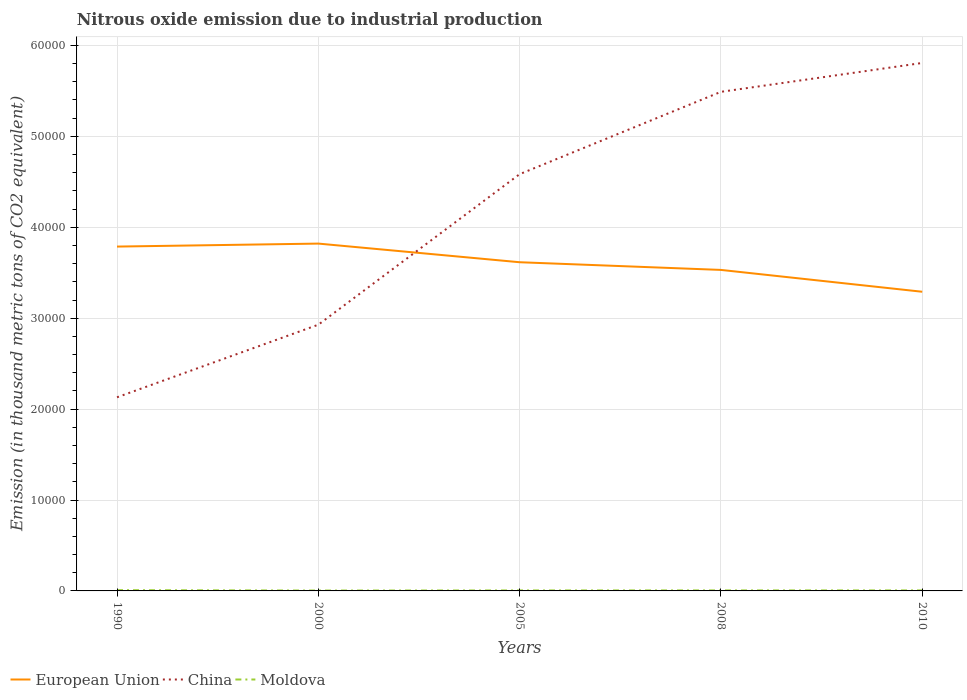How many different coloured lines are there?
Offer a very short reply. 3. Is the number of lines equal to the number of legend labels?
Offer a very short reply. Yes. Across all years, what is the maximum amount of nitrous oxide emitted in China?
Give a very brief answer. 2.13e+04. What is the total amount of nitrous oxide emitted in Moldova in the graph?
Keep it short and to the point. 29.4. What is the difference between the highest and the second highest amount of nitrous oxide emitted in China?
Offer a terse response. 3.68e+04. Is the amount of nitrous oxide emitted in China strictly greater than the amount of nitrous oxide emitted in Moldova over the years?
Your answer should be very brief. No. How many lines are there?
Ensure brevity in your answer.  3. Does the graph contain any zero values?
Your answer should be very brief. No. Where does the legend appear in the graph?
Make the answer very short. Bottom left. How many legend labels are there?
Provide a short and direct response. 3. What is the title of the graph?
Provide a short and direct response. Nitrous oxide emission due to industrial production. Does "French Polynesia" appear as one of the legend labels in the graph?
Provide a succinct answer. No. What is the label or title of the X-axis?
Your response must be concise. Years. What is the label or title of the Y-axis?
Offer a terse response. Emission (in thousand metric tons of CO2 equivalent). What is the Emission (in thousand metric tons of CO2 equivalent) in European Union in 1990?
Provide a succinct answer. 3.79e+04. What is the Emission (in thousand metric tons of CO2 equivalent) in China in 1990?
Your response must be concise. 2.13e+04. What is the Emission (in thousand metric tons of CO2 equivalent) in Moldova in 1990?
Ensure brevity in your answer.  84.7. What is the Emission (in thousand metric tons of CO2 equivalent) in European Union in 2000?
Give a very brief answer. 3.82e+04. What is the Emission (in thousand metric tons of CO2 equivalent) in China in 2000?
Your answer should be very brief. 2.93e+04. What is the Emission (in thousand metric tons of CO2 equivalent) of Moldova in 2000?
Provide a short and direct response. 40.8. What is the Emission (in thousand metric tons of CO2 equivalent) in European Union in 2005?
Your response must be concise. 3.62e+04. What is the Emission (in thousand metric tons of CO2 equivalent) in China in 2005?
Your answer should be compact. 4.58e+04. What is the Emission (in thousand metric tons of CO2 equivalent) in Moldova in 2005?
Your answer should be very brief. 52.6. What is the Emission (in thousand metric tons of CO2 equivalent) of European Union in 2008?
Keep it short and to the point. 3.53e+04. What is the Emission (in thousand metric tons of CO2 equivalent) of China in 2008?
Provide a short and direct response. 5.49e+04. What is the Emission (in thousand metric tons of CO2 equivalent) in Moldova in 2008?
Provide a short and direct response. 55.7. What is the Emission (in thousand metric tons of CO2 equivalent) of European Union in 2010?
Provide a short and direct response. 3.29e+04. What is the Emission (in thousand metric tons of CO2 equivalent) in China in 2010?
Provide a short and direct response. 5.81e+04. What is the Emission (in thousand metric tons of CO2 equivalent) of Moldova in 2010?
Provide a short and direct response. 55.3. Across all years, what is the maximum Emission (in thousand metric tons of CO2 equivalent) of European Union?
Make the answer very short. 3.82e+04. Across all years, what is the maximum Emission (in thousand metric tons of CO2 equivalent) in China?
Offer a terse response. 5.81e+04. Across all years, what is the maximum Emission (in thousand metric tons of CO2 equivalent) of Moldova?
Give a very brief answer. 84.7. Across all years, what is the minimum Emission (in thousand metric tons of CO2 equivalent) of European Union?
Provide a succinct answer. 3.29e+04. Across all years, what is the minimum Emission (in thousand metric tons of CO2 equivalent) in China?
Make the answer very short. 2.13e+04. Across all years, what is the minimum Emission (in thousand metric tons of CO2 equivalent) in Moldova?
Your answer should be very brief. 40.8. What is the total Emission (in thousand metric tons of CO2 equivalent) of European Union in the graph?
Provide a short and direct response. 1.80e+05. What is the total Emission (in thousand metric tons of CO2 equivalent) in China in the graph?
Offer a very short reply. 2.09e+05. What is the total Emission (in thousand metric tons of CO2 equivalent) of Moldova in the graph?
Ensure brevity in your answer.  289.1. What is the difference between the Emission (in thousand metric tons of CO2 equivalent) in European Union in 1990 and that in 2000?
Your answer should be very brief. -328.9. What is the difference between the Emission (in thousand metric tons of CO2 equivalent) of China in 1990 and that in 2000?
Keep it short and to the point. -7984.9. What is the difference between the Emission (in thousand metric tons of CO2 equivalent) of Moldova in 1990 and that in 2000?
Provide a succinct answer. 43.9. What is the difference between the Emission (in thousand metric tons of CO2 equivalent) of European Union in 1990 and that in 2005?
Offer a very short reply. 1721.7. What is the difference between the Emission (in thousand metric tons of CO2 equivalent) in China in 1990 and that in 2005?
Keep it short and to the point. -2.45e+04. What is the difference between the Emission (in thousand metric tons of CO2 equivalent) of Moldova in 1990 and that in 2005?
Your answer should be very brief. 32.1. What is the difference between the Emission (in thousand metric tons of CO2 equivalent) in European Union in 1990 and that in 2008?
Offer a very short reply. 2566.7. What is the difference between the Emission (in thousand metric tons of CO2 equivalent) of China in 1990 and that in 2008?
Offer a terse response. -3.36e+04. What is the difference between the Emission (in thousand metric tons of CO2 equivalent) of Moldova in 1990 and that in 2008?
Your response must be concise. 29. What is the difference between the Emission (in thousand metric tons of CO2 equivalent) in European Union in 1990 and that in 2010?
Offer a very short reply. 4969.2. What is the difference between the Emission (in thousand metric tons of CO2 equivalent) in China in 1990 and that in 2010?
Keep it short and to the point. -3.68e+04. What is the difference between the Emission (in thousand metric tons of CO2 equivalent) in Moldova in 1990 and that in 2010?
Make the answer very short. 29.4. What is the difference between the Emission (in thousand metric tons of CO2 equivalent) in European Union in 2000 and that in 2005?
Your response must be concise. 2050.6. What is the difference between the Emission (in thousand metric tons of CO2 equivalent) of China in 2000 and that in 2005?
Offer a terse response. -1.66e+04. What is the difference between the Emission (in thousand metric tons of CO2 equivalent) of European Union in 2000 and that in 2008?
Give a very brief answer. 2895.6. What is the difference between the Emission (in thousand metric tons of CO2 equivalent) of China in 2000 and that in 2008?
Offer a terse response. -2.56e+04. What is the difference between the Emission (in thousand metric tons of CO2 equivalent) in Moldova in 2000 and that in 2008?
Make the answer very short. -14.9. What is the difference between the Emission (in thousand metric tons of CO2 equivalent) in European Union in 2000 and that in 2010?
Offer a very short reply. 5298.1. What is the difference between the Emission (in thousand metric tons of CO2 equivalent) in China in 2000 and that in 2010?
Give a very brief answer. -2.88e+04. What is the difference between the Emission (in thousand metric tons of CO2 equivalent) in Moldova in 2000 and that in 2010?
Provide a succinct answer. -14.5. What is the difference between the Emission (in thousand metric tons of CO2 equivalent) in European Union in 2005 and that in 2008?
Your answer should be very brief. 845. What is the difference between the Emission (in thousand metric tons of CO2 equivalent) in China in 2005 and that in 2008?
Provide a succinct answer. -9056.8. What is the difference between the Emission (in thousand metric tons of CO2 equivalent) of European Union in 2005 and that in 2010?
Make the answer very short. 3247.5. What is the difference between the Emission (in thousand metric tons of CO2 equivalent) in China in 2005 and that in 2010?
Your answer should be very brief. -1.22e+04. What is the difference between the Emission (in thousand metric tons of CO2 equivalent) of European Union in 2008 and that in 2010?
Give a very brief answer. 2402.5. What is the difference between the Emission (in thousand metric tons of CO2 equivalent) of China in 2008 and that in 2010?
Make the answer very short. -3175.5. What is the difference between the Emission (in thousand metric tons of CO2 equivalent) of European Union in 1990 and the Emission (in thousand metric tons of CO2 equivalent) of China in 2000?
Make the answer very short. 8592.7. What is the difference between the Emission (in thousand metric tons of CO2 equivalent) of European Union in 1990 and the Emission (in thousand metric tons of CO2 equivalent) of Moldova in 2000?
Provide a succinct answer. 3.78e+04. What is the difference between the Emission (in thousand metric tons of CO2 equivalent) in China in 1990 and the Emission (in thousand metric tons of CO2 equivalent) in Moldova in 2000?
Your response must be concise. 2.13e+04. What is the difference between the Emission (in thousand metric tons of CO2 equivalent) in European Union in 1990 and the Emission (in thousand metric tons of CO2 equivalent) in China in 2005?
Ensure brevity in your answer.  -7965.7. What is the difference between the Emission (in thousand metric tons of CO2 equivalent) of European Union in 1990 and the Emission (in thousand metric tons of CO2 equivalent) of Moldova in 2005?
Keep it short and to the point. 3.78e+04. What is the difference between the Emission (in thousand metric tons of CO2 equivalent) of China in 1990 and the Emission (in thousand metric tons of CO2 equivalent) of Moldova in 2005?
Your response must be concise. 2.12e+04. What is the difference between the Emission (in thousand metric tons of CO2 equivalent) in European Union in 1990 and the Emission (in thousand metric tons of CO2 equivalent) in China in 2008?
Your answer should be compact. -1.70e+04. What is the difference between the Emission (in thousand metric tons of CO2 equivalent) of European Union in 1990 and the Emission (in thousand metric tons of CO2 equivalent) of Moldova in 2008?
Offer a very short reply. 3.78e+04. What is the difference between the Emission (in thousand metric tons of CO2 equivalent) of China in 1990 and the Emission (in thousand metric tons of CO2 equivalent) of Moldova in 2008?
Offer a terse response. 2.12e+04. What is the difference between the Emission (in thousand metric tons of CO2 equivalent) of European Union in 1990 and the Emission (in thousand metric tons of CO2 equivalent) of China in 2010?
Keep it short and to the point. -2.02e+04. What is the difference between the Emission (in thousand metric tons of CO2 equivalent) in European Union in 1990 and the Emission (in thousand metric tons of CO2 equivalent) in Moldova in 2010?
Make the answer very short. 3.78e+04. What is the difference between the Emission (in thousand metric tons of CO2 equivalent) in China in 1990 and the Emission (in thousand metric tons of CO2 equivalent) in Moldova in 2010?
Your answer should be compact. 2.12e+04. What is the difference between the Emission (in thousand metric tons of CO2 equivalent) of European Union in 2000 and the Emission (in thousand metric tons of CO2 equivalent) of China in 2005?
Offer a terse response. -7636.8. What is the difference between the Emission (in thousand metric tons of CO2 equivalent) of European Union in 2000 and the Emission (in thousand metric tons of CO2 equivalent) of Moldova in 2005?
Make the answer very short. 3.82e+04. What is the difference between the Emission (in thousand metric tons of CO2 equivalent) of China in 2000 and the Emission (in thousand metric tons of CO2 equivalent) of Moldova in 2005?
Your response must be concise. 2.92e+04. What is the difference between the Emission (in thousand metric tons of CO2 equivalent) in European Union in 2000 and the Emission (in thousand metric tons of CO2 equivalent) in China in 2008?
Your answer should be very brief. -1.67e+04. What is the difference between the Emission (in thousand metric tons of CO2 equivalent) of European Union in 2000 and the Emission (in thousand metric tons of CO2 equivalent) of Moldova in 2008?
Your response must be concise. 3.81e+04. What is the difference between the Emission (in thousand metric tons of CO2 equivalent) of China in 2000 and the Emission (in thousand metric tons of CO2 equivalent) of Moldova in 2008?
Keep it short and to the point. 2.92e+04. What is the difference between the Emission (in thousand metric tons of CO2 equivalent) of European Union in 2000 and the Emission (in thousand metric tons of CO2 equivalent) of China in 2010?
Ensure brevity in your answer.  -1.99e+04. What is the difference between the Emission (in thousand metric tons of CO2 equivalent) in European Union in 2000 and the Emission (in thousand metric tons of CO2 equivalent) in Moldova in 2010?
Keep it short and to the point. 3.81e+04. What is the difference between the Emission (in thousand metric tons of CO2 equivalent) in China in 2000 and the Emission (in thousand metric tons of CO2 equivalent) in Moldova in 2010?
Offer a terse response. 2.92e+04. What is the difference between the Emission (in thousand metric tons of CO2 equivalent) in European Union in 2005 and the Emission (in thousand metric tons of CO2 equivalent) in China in 2008?
Make the answer very short. -1.87e+04. What is the difference between the Emission (in thousand metric tons of CO2 equivalent) in European Union in 2005 and the Emission (in thousand metric tons of CO2 equivalent) in Moldova in 2008?
Ensure brevity in your answer.  3.61e+04. What is the difference between the Emission (in thousand metric tons of CO2 equivalent) in China in 2005 and the Emission (in thousand metric tons of CO2 equivalent) in Moldova in 2008?
Your answer should be very brief. 4.58e+04. What is the difference between the Emission (in thousand metric tons of CO2 equivalent) in European Union in 2005 and the Emission (in thousand metric tons of CO2 equivalent) in China in 2010?
Your response must be concise. -2.19e+04. What is the difference between the Emission (in thousand metric tons of CO2 equivalent) of European Union in 2005 and the Emission (in thousand metric tons of CO2 equivalent) of Moldova in 2010?
Your answer should be very brief. 3.61e+04. What is the difference between the Emission (in thousand metric tons of CO2 equivalent) of China in 2005 and the Emission (in thousand metric tons of CO2 equivalent) of Moldova in 2010?
Make the answer very short. 4.58e+04. What is the difference between the Emission (in thousand metric tons of CO2 equivalent) of European Union in 2008 and the Emission (in thousand metric tons of CO2 equivalent) of China in 2010?
Offer a very short reply. -2.28e+04. What is the difference between the Emission (in thousand metric tons of CO2 equivalent) in European Union in 2008 and the Emission (in thousand metric tons of CO2 equivalent) in Moldova in 2010?
Ensure brevity in your answer.  3.53e+04. What is the difference between the Emission (in thousand metric tons of CO2 equivalent) in China in 2008 and the Emission (in thousand metric tons of CO2 equivalent) in Moldova in 2010?
Keep it short and to the point. 5.48e+04. What is the average Emission (in thousand metric tons of CO2 equivalent) in European Union per year?
Keep it short and to the point. 3.61e+04. What is the average Emission (in thousand metric tons of CO2 equivalent) of China per year?
Your answer should be very brief. 4.19e+04. What is the average Emission (in thousand metric tons of CO2 equivalent) of Moldova per year?
Provide a short and direct response. 57.82. In the year 1990, what is the difference between the Emission (in thousand metric tons of CO2 equivalent) of European Union and Emission (in thousand metric tons of CO2 equivalent) of China?
Make the answer very short. 1.66e+04. In the year 1990, what is the difference between the Emission (in thousand metric tons of CO2 equivalent) in European Union and Emission (in thousand metric tons of CO2 equivalent) in Moldova?
Provide a succinct answer. 3.78e+04. In the year 1990, what is the difference between the Emission (in thousand metric tons of CO2 equivalent) of China and Emission (in thousand metric tons of CO2 equivalent) of Moldova?
Give a very brief answer. 2.12e+04. In the year 2000, what is the difference between the Emission (in thousand metric tons of CO2 equivalent) of European Union and Emission (in thousand metric tons of CO2 equivalent) of China?
Ensure brevity in your answer.  8921.6. In the year 2000, what is the difference between the Emission (in thousand metric tons of CO2 equivalent) in European Union and Emission (in thousand metric tons of CO2 equivalent) in Moldova?
Ensure brevity in your answer.  3.82e+04. In the year 2000, what is the difference between the Emission (in thousand metric tons of CO2 equivalent) of China and Emission (in thousand metric tons of CO2 equivalent) of Moldova?
Provide a succinct answer. 2.92e+04. In the year 2005, what is the difference between the Emission (in thousand metric tons of CO2 equivalent) of European Union and Emission (in thousand metric tons of CO2 equivalent) of China?
Offer a very short reply. -9687.4. In the year 2005, what is the difference between the Emission (in thousand metric tons of CO2 equivalent) in European Union and Emission (in thousand metric tons of CO2 equivalent) in Moldova?
Provide a succinct answer. 3.61e+04. In the year 2005, what is the difference between the Emission (in thousand metric tons of CO2 equivalent) in China and Emission (in thousand metric tons of CO2 equivalent) in Moldova?
Your response must be concise. 4.58e+04. In the year 2008, what is the difference between the Emission (in thousand metric tons of CO2 equivalent) of European Union and Emission (in thousand metric tons of CO2 equivalent) of China?
Offer a terse response. -1.96e+04. In the year 2008, what is the difference between the Emission (in thousand metric tons of CO2 equivalent) in European Union and Emission (in thousand metric tons of CO2 equivalent) in Moldova?
Offer a very short reply. 3.53e+04. In the year 2008, what is the difference between the Emission (in thousand metric tons of CO2 equivalent) in China and Emission (in thousand metric tons of CO2 equivalent) in Moldova?
Give a very brief answer. 5.48e+04. In the year 2010, what is the difference between the Emission (in thousand metric tons of CO2 equivalent) in European Union and Emission (in thousand metric tons of CO2 equivalent) in China?
Provide a succinct answer. -2.52e+04. In the year 2010, what is the difference between the Emission (in thousand metric tons of CO2 equivalent) in European Union and Emission (in thousand metric tons of CO2 equivalent) in Moldova?
Give a very brief answer. 3.29e+04. In the year 2010, what is the difference between the Emission (in thousand metric tons of CO2 equivalent) of China and Emission (in thousand metric tons of CO2 equivalent) of Moldova?
Your answer should be compact. 5.80e+04. What is the ratio of the Emission (in thousand metric tons of CO2 equivalent) of China in 1990 to that in 2000?
Your answer should be very brief. 0.73. What is the ratio of the Emission (in thousand metric tons of CO2 equivalent) in Moldova in 1990 to that in 2000?
Your answer should be compact. 2.08. What is the ratio of the Emission (in thousand metric tons of CO2 equivalent) of European Union in 1990 to that in 2005?
Provide a short and direct response. 1.05. What is the ratio of the Emission (in thousand metric tons of CO2 equivalent) in China in 1990 to that in 2005?
Keep it short and to the point. 0.46. What is the ratio of the Emission (in thousand metric tons of CO2 equivalent) in Moldova in 1990 to that in 2005?
Give a very brief answer. 1.61. What is the ratio of the Emission (in thousand metric tons of CO2 equivalent) in European Union in 1990 to that in 2008?
Your response must be concise. 1.07. What is the ratio of the Emission (in thousand metric tons of CO2 equivalent) in China in 1990 to that in 2008?
Provide a short and direct response. 0.39. What is the ratio of the Emission (in thousand metric tons of CO2 equivalent) of Moldova in 1990 to that in 2008?
Your answer should be very brief. 1.52. What is the ratio of the Emission (in thousand metric tons of CO2 equivalent) of European Union in 1990 to that in 2010?
Offer a terse response. 1.15. What is the ratio of the Emission (in thousand metric tons of CO2 equivalent) of China in 1990 to that in 2010?
Your answer should be compact. 0.37. What is the ratio of the Emission (in thousand metric tons of CO2 equivalent) of Moldova in 1990 to that in 2010?
Make the answer very short. 1.53. What is the ratio of the Emission (in thousand metric tons of CO2 equivalent) in European Union in 2000 to that in 2005?
Provide a succinct answer. 1.06. What is the ratio of the Emission (in thousand metric tons of CO2 equivalent) of China in 2000 to that in 2005?
Offer a very short reply. 0.64. What is the ratio of the Emission (in thousand metric tons of CO2 equivalent) in Moldova in 2000 to that in 2005?
Offer a terse response. 0.78. What is the ratio of the Emission (in thousand metric tons of CO2 equivalent) of European Union in 2000 to that in 2008?
Offer a terse response. 1.08. What is the ratio of the Emission (in thousand metric tons of CO2 equivalent) in China in 2000 to that in 2008?
Keep it short and to the point. 0.53. What is the ratio of the Emission (in thousand metric tons of CO2 equivalent) in Moldova in 2000 to that in 2008?
Offer a terse response. 0.73. What is the ratio of the Emission (in thousand metric tons of CO2 equivalent) in European Union in 2000 to that in 2010?
Your response must be concise. 1.16. What is the ratio of the Emission (in thousand metric tons of CO2 equivalent) of China in 2000 to that in 2010?
Keep it short and to the point. 0.5. What is the ratio of the Emission (in thousand metric tons of CO2 equivalent) of Moldova in 2000 to that in 2010?
Provide a short and direct response. 0.74. What is the ratio of the Emission (in thousand metric tons of CO2 equivalent) of European Union in 2005 to that in 2008?
Give a very brief answer. 1.02. What is the ratio of the Emission (in thousand metric tons of CO2 equivalent) in China in 2005 to that in 2008?
Your answer should be very brief. 0.83. What is the ratio of the Emission (in thousand metric tons of CO2 equivalent) in Moldova in 2005 to that in 2008?
Ensure brevity in your answer.  0.94. What is the ratio of the Emission (in thousand metric tons of CO2 equivalent) in European Union in 2005 to that in 2010?
Offer a very short reply. 1.1. What is the ratio of the Emission (in thousand metric tons of CO2 equivalent) of China in 2005 to that in 2010?
Offer a terse response. 0.79. What is the ratio of the Emission (in thousand metric tons of CO2 equivalent) in Moldova in 2005 to that in 2010?
Your answer should be very brief. 0.95. What is the ratio of the Emission (in thousand metric tons of CO2 equivalent) of European Union in 2008 to that in 2010?
Offer a very short reply. 1.07. What is the ratio of the Emission (in thousand metric tons of CO2 equivalent) in China in 2008 to that in 2010?
Your answer should be compact. 0.95. What is the ratio of the Emission (in thousand metric tons of CO2 equivalent) of Moldova in 2008 to that in 2010?
Your response must be concise. 1.01. What is the difference between the highest and the second highest Emission (in thousand metric tons of CO2 equivalent) of European Union?
Make the answer very short. 328.9. What is the difference between the highest and the second highest Emission (in thousand metric tons of CO2 equivalent) in China?
Your answer should be compact. 3175.5. What is the difference between the highest and the lowest Emission (in thousand metric tons of CO2 equivalent) in European Union?
Your answer should be compact. 5298.1. What is the difference between the highest and the lowest Emission (in thousand metric tons of CO2 equivalent) of China?
Your answer should be very brief. 3.68e+04. What is the difference between the highest and the lowest Emission (in thousand metric tons of CO2 equivalent) in Moldova?
Ensure brevity in your answer.  43.9. 